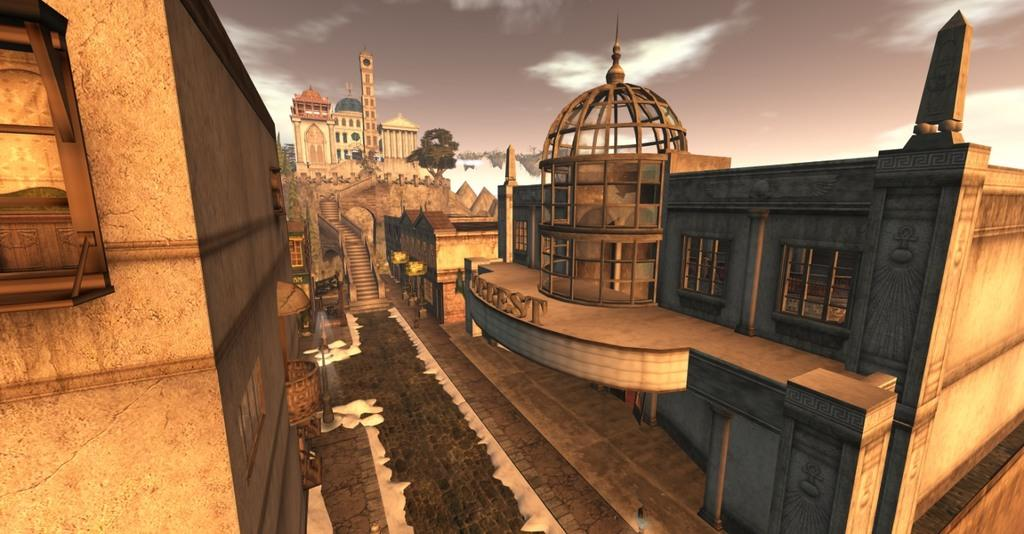What type of structures can be seen in the image? There are buildings and a palace in the image. Are there any architectural features that stand out? Yes, there are stairs and a walkway in the image. What else can be seen in the image besides structures? There are poles and trees in the image. What is visible at the top of the image? The sky is visible at the top of the image. What type of division is taking place in the image? There is no division taking place in the image; it features a palace, buildings, stairs, a walkway, poles, trees, and the sky. Can you tell me the name of the judge presiding over the case in the image? There is no case or judge present in the image. 